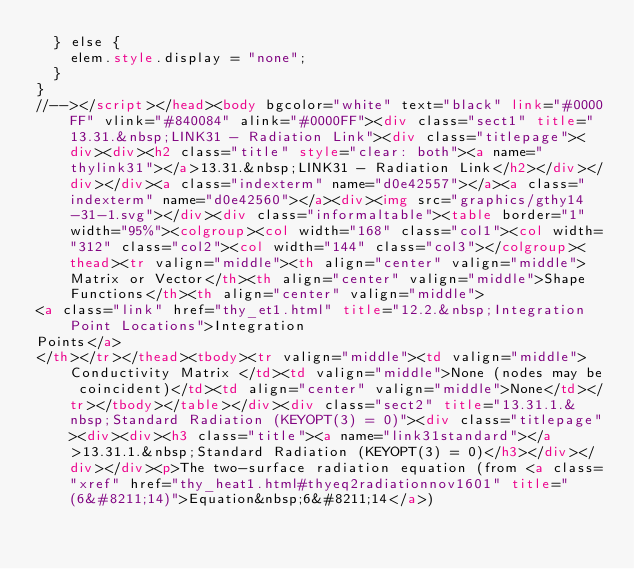<code> <loc_0><loc_0><loc_500><loc_500><_HTML_>  } else {
    elem.style.display = "none";
  }
}
//--></script></head><body bgcolor="white" text="black" link="#0000FF" vlink="#840084" alink="#0000FF"><div class="sect1" title="13.31.&nbsp;LINK31 - Radiation Link"><div class="titlepage"><div><div><h2 class="title" style="clear: both"><a name="thylink31"></a>13.31.&nbsp;LINK31 - Radiation Link</h2></div></div></div><a class="indexterm" name="d0e42557"></a><a class="indexterm" name="d0e42560"></a><div><img src="graphics/gthy14-31-1.svg"></div><div class="informaltable"><table border="1" width="95%"><colgroup><col width="168" class="col1"><col width="312" class="col2"><col width="144" class="col3"></colgroup><thead><tr valign="middle"><th align="center" valign="middle">Matrix or Vector</th><th align="center" valign="middle">Shape Functions</th><th align="center" valign="middle">
<a class="link" href="thy_et1.html" title="12.2.&nbsp;Integration Point Locations">Integration
Points</a>
</th></tr></thead><tbody><tr valign="middle"><td valign="middle">Conductivity Matrix </td><td valign="middle">None (nodes may be coincident)</td><td align="center" valign="middle">None</td></tr></tbody></table></div><div class="sect2" title="13.31.1.&nbsp;Standard Radiation (KEYOPT(3) = 0)"><div class="titlepage"><div><div><h3 class="title"><a name="link31standard"></a>13.31.1.&nbsp;Standard Radiation (KEYOPT(3) = 0)</h3></div></div></div><p>The two-surface radiation equation (from <a class="xref" href="thy_heat1.html#thyeq2radiationnov1601" title="(6&#8211;14)">Equation&nbsp;6&#8211;14</a>)</code> 